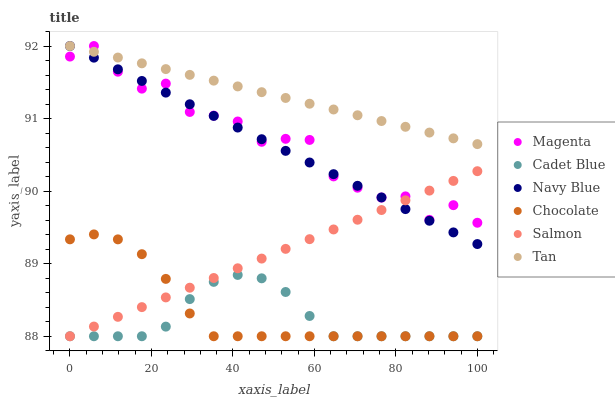Does Cadet Blue have the minimum area under the curve?
Answer yes or no. Yes. Does Tan have the maximum area under the curve?
Answer yes or no. Yes. Does Navy Blue have the minimum area under the curve?
Answer yes or no. No. Does Navy Blue have the maximum area under the curve?
Answer yes or no. No. Is Tan the smoothest?
Answer yes or no. Yes. Is Magenta the roughest?
Answer yes or no. Yes. Is Navy Blue the smoothest?
Answer yes or no. No. Is Navy Blue the roughest?
Answer yes or no. No. Does Cadet Blue have the lowest value?
Answer yes or no. Yes. Does Navy Blue have the lowest value?
Answer yes or no. No. Does Tan have the highest value?
Answer yes or no. Yes. Does Salmon have the highest value?
Answer yes or no. No. Is Salmon less than Tan?
Answer yes or no. Yes. Is Navy Blue greater than Chocolate?
Answer yes or no. Yes. Does Salmon intersect Cadet Blue?
Answer yes or no. Yes. Is Salmon less than Cadet Blue?
Answer yes or no. No. Is Salmon greater than Cadet Blue?
Answer yes or no. No. Does Salmon intersect Tan?
Answer yes or no. No. 